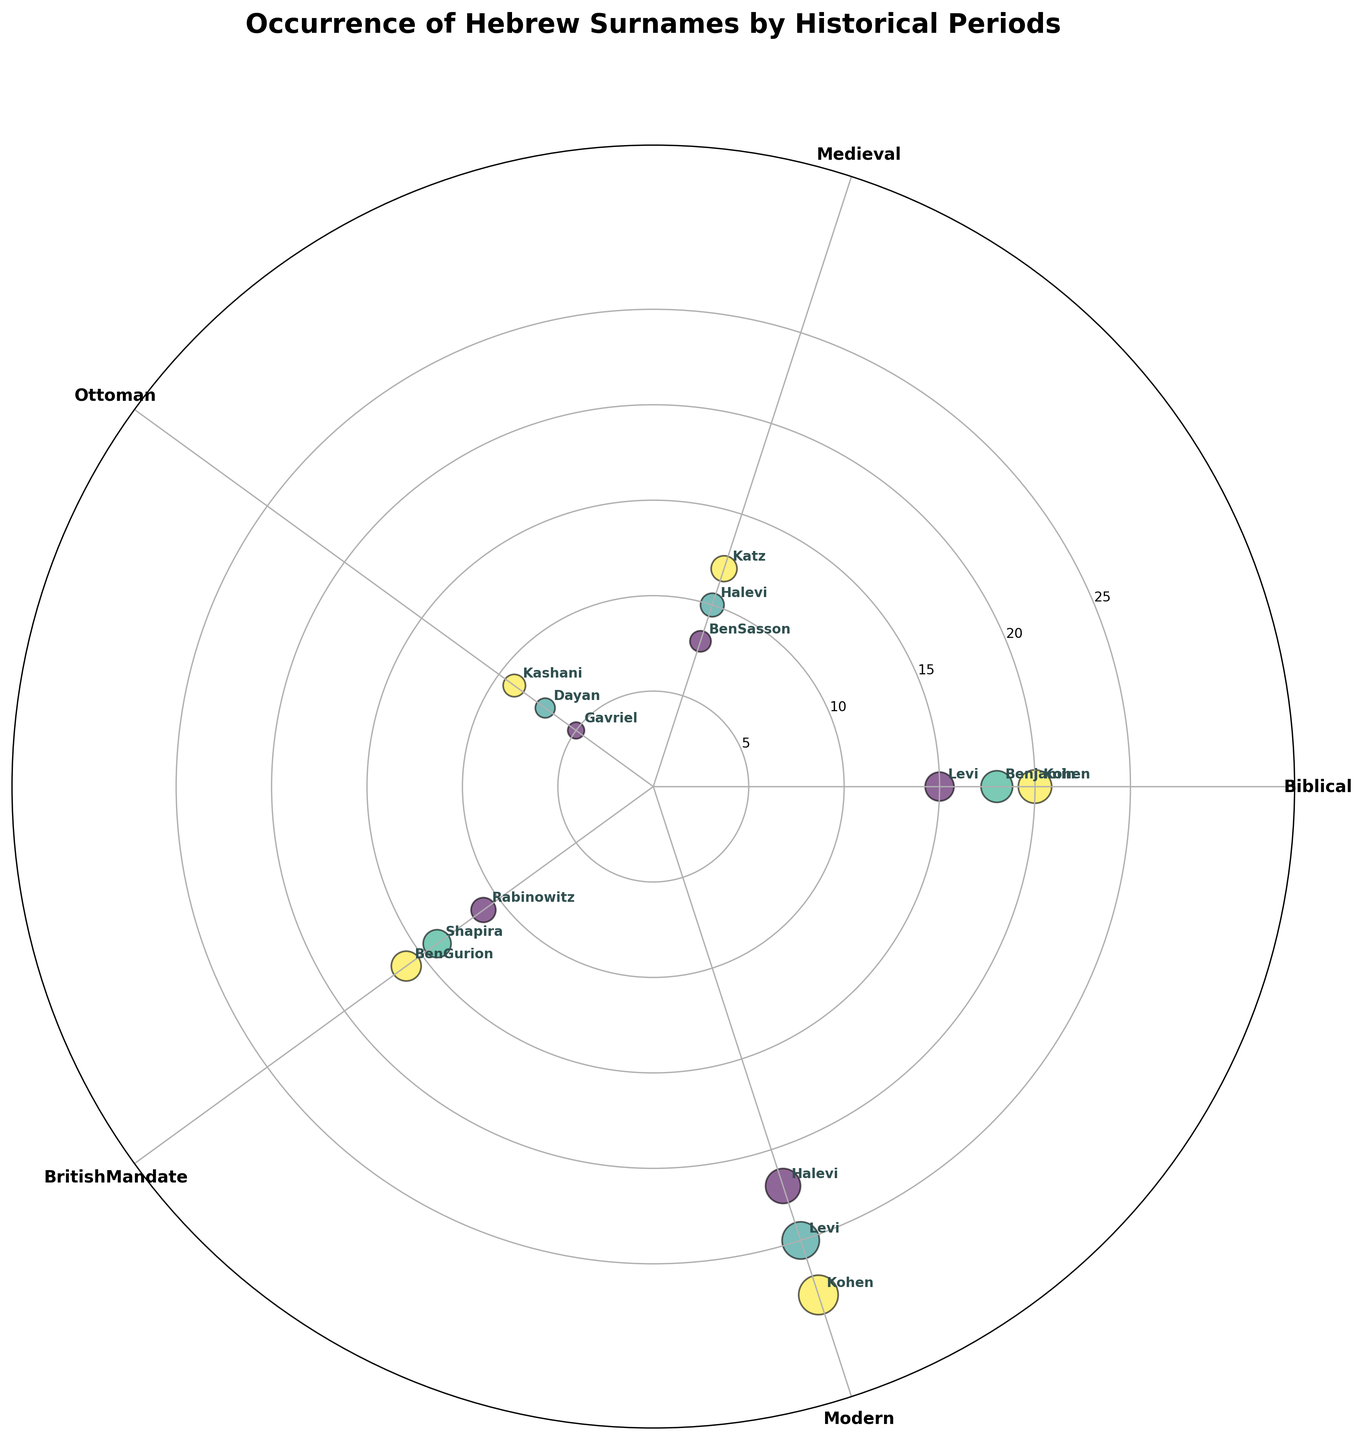What is the title of the plot? The title is placed at the top of the chart and is usually both large and bold to catch attention. The title here gives a brief description of what the chart represents.
Answer: Occurrence of Hebrew Surnames by Historical Periods How many historical periods are represented in the chart? By looking at the labels around the polar graph, we can count the number of unique periods mentioned.
Answer: 5 Which surname has the highest occurrence in the Modern period? By finding the “Modern” segment and locating the data points within it, we can identify the surname with the highest radial distance (point furthest from the center).
Answer: Kohen What is the combined occurrence of the surname "Levi" across all historical periods? First, identify each data point labeled "Levi" and note its occurrence. Then, sum these values.
Answer: 15 (Biblical) + 25 (Modern) = 40 Which historical period had the least diverse set of Hebrew surnames in terms of distinct surnames? By counting the number of distinct surnames per period, we compare the number of unique labels within each period.
Answer: Ottoman (3 surnames) How does the occurrence of "Halevi" in the Medieval period compare to its occurrence in the Modern period? Locate the points for "Halevi" in both the Medieval and Modern segments and compare their occurrences.
Answer: 10 (Medieval) vs. 22 (Modern) What is the average occurrence of all surnames in the Biblical period? Sum the occurrence values of all surnames in the Biblical period and divide by the number of surnames in that period.
Answer: (15 + 20 + 18) / 3 = 53 / 3 = 17.67 (approximately) Which surname appears in both the Biblical and Modern periods? Identify surnames that are labeled in both the Biblical and Modern segments of the chart.
Answer: Levi What is the angle (in radians) associated with the British Mandate period? The positions around the polar chart can be mapped to specific angles. Since there are 5 periods (Biblical, Medieval, Ottoman, British Mandate, Modern) evenly spaced around the circle and 2π radians equal 360 degrees, the angle can be calculated as 2π/5.
Answer: 2π/5 radians In which historical period does the surname "Rabinowitz" appear and what is its occurrence? Locate the point labeled "Rabinowitz" on the chart and note the historical period and radial distance (occurrence) of the point.
Answer: British Mandate, 11 